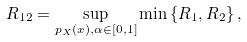Convert formula to latex. <formula><loc_0><loc_0><loc_500><loc_500>R _ { 1 2 } = \sup _ { p _ { X } ( x ) , \alpha \in [ 0 , 1 ] } \min \left \{ R _ { 1 } , R _ { 2 } \right \} ,</formula> 